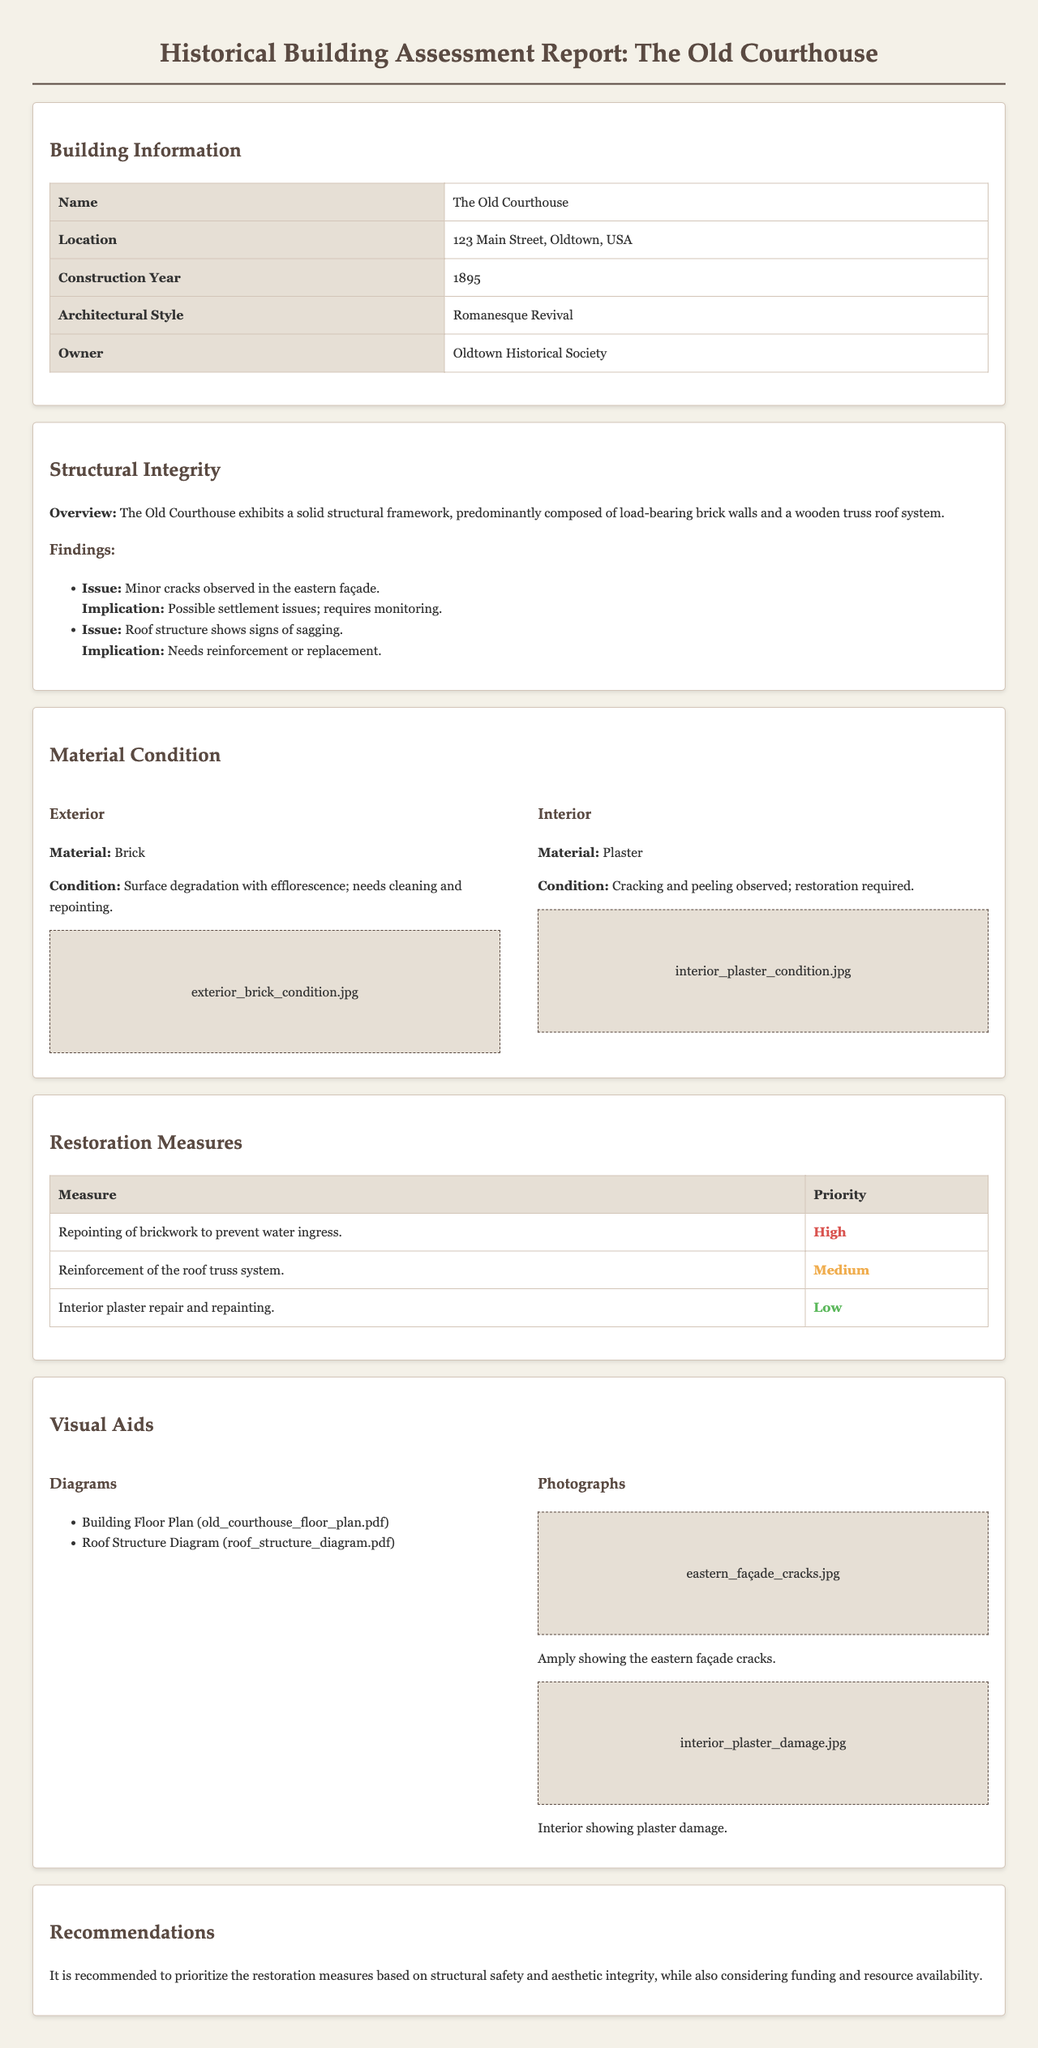What is the name of the building? The name of the building is specified in the report's title and is The Old Courthouse.
Answer: The Old Courthouse What year was the building constructed? The construction year is provided in the 'Building Information' section of the report and is listed as 1895.
Answer: 1895 Which architectural style does the building represent? The architectural style is mentioned in the 'Building Information' section and is described as Romanesque Revival.
Answer: Romanesque Revival What priority level is assigned to the repointing of brickwork? The priority for this restoration measure is indicated in the 'Restoration Measures' table and is classified as High.
Answer: High What material is primarily used in the building’s exterior? The material of the exterior is described in the 'Material Condition' section, specifically identified as Brick.
Answer: Brick What specific issue is observed in the roof structure? The 'Structural Integrity' section points out signs of sagging in the roof structure as an issue.
Answer: Sagging Which organization owns The Old Courthouse? The owner is indicated in the 'Building Information' section, which lists the Oldtown Historical Society as the owner.
Answer: Oldtown Historical Society What is the condition of the interior material? The condition of the interior plaster is mentioned as cracking and peeling, needing restoration.
Answer: Cracking and peeling How many diagrams are included in the report? The 'Visual Aids' section lists two diagrams, indicating the number of diagrams included.
Answer: Two 